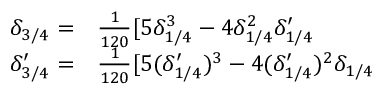<formula> <loc_0><loc_0><loc_500><loc_500>\begin{array} { r l } { \delta _ { 3 / 4 } = } & \frac { 1 } { 1 2 0 } [ 5 \delta _ { 1 / 4 } ^ { 3 } - 4 \delta _ { 1 / 4 } ^ { 2 } \delta _ { 1 / 4 } ^ { \prime } } \\ { \delta _ { 3 / 4 } ^ { \prime } = } & \frac { 1 } { 1 2 0 } [ 5 ( \delta _ { 1 / 4 } ^ { \prime } ) ^ { 3 } - 4 ( \delta _ { 1 / 4 } ^ { \prime } ) ^ { 2 } \delta _ { 1 / 4 } } \end{array}</formula> 